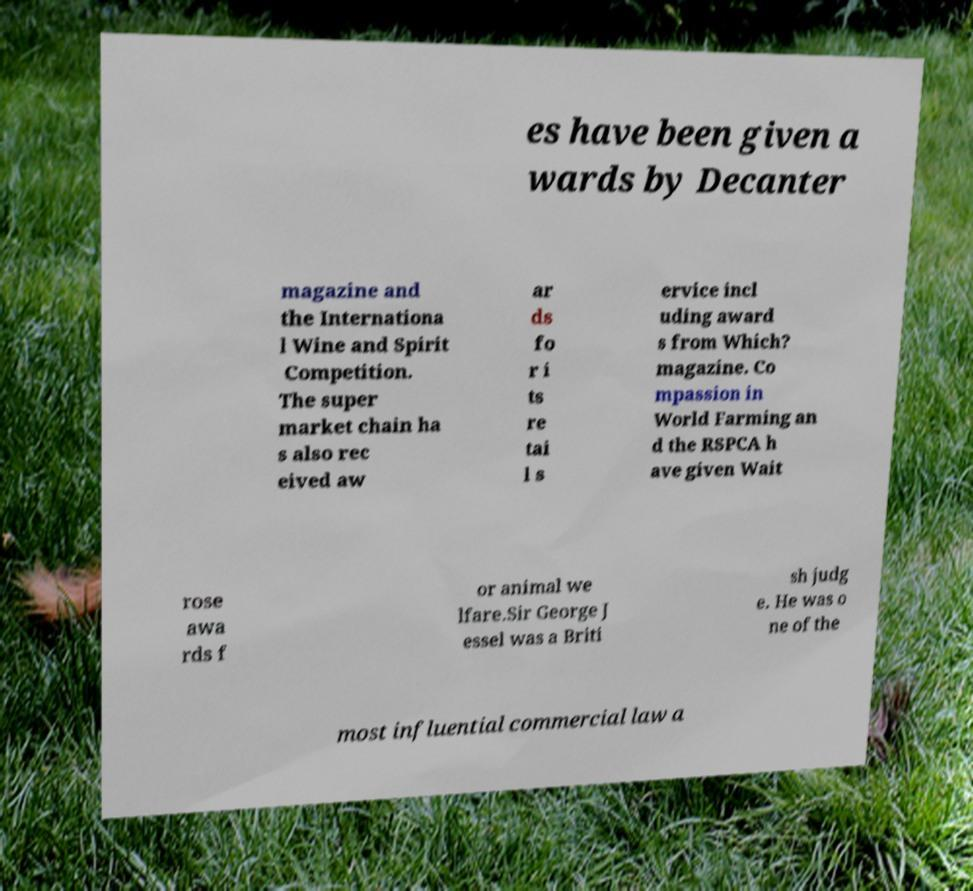Could you extract and type out the text from this image? es have been given a wards by Decanter magazine and the Internationa l Wine and Spirit Competition. The super market chain ha s also rec eived aw ar ds fo r i ts re tai l s ervice incl uding award s from Which? magazine. Co mpassion in World Farming an d the RSPCA h ave given Wait rose awa rds f or animal we lfare.Sir George J essel was a Briti sh judg e. He was o ne of the most influential commercial law a 